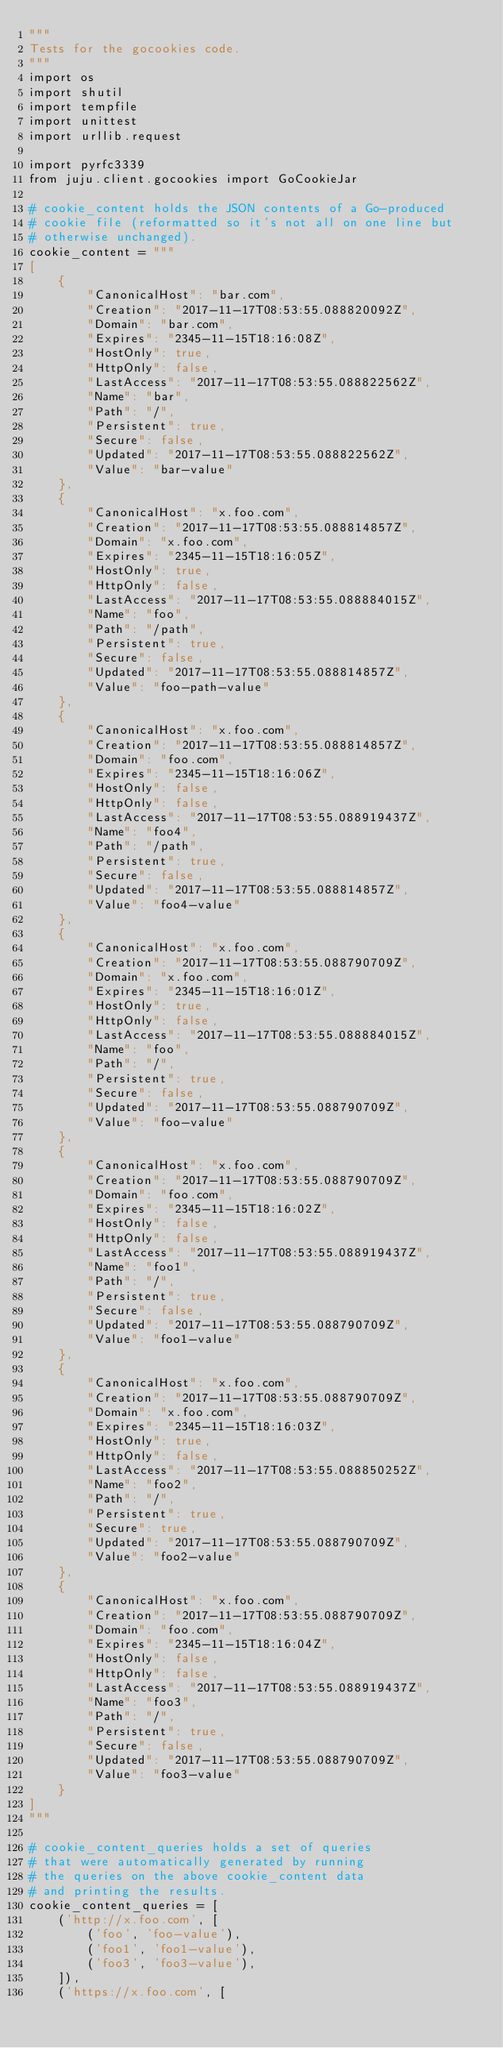<code> <loc_0><loc_0><loc_500><loc_500><_Python_>"""
Tests for the gocookies code.
"""
import os
import shutil
import tempfile
import unittest
import urllib.request

import pyrfc3339
from juju.client.gocookies import GoCookieJar

# cookie_content holds the JSON contents of a Go-produced
# cookie file (reformatted so it's not all on one line but
# otherwise unchanged).
cookie_content = """
[
    {
        "CanonicalHost": "bar.com",
        "Creation": "2017-11-17T08:53:55.088820092Z",
        "Domain": "bar.com",
        "Expires": "2345-11-15T18:16:08Z",
        "HostOnly": true,
        "HttpOnly": false,
        "LastAccess": "2017-11-17T08:53:55.088822562Z",
        "Name": "bar",
        "Path": "/",
        "Persistent": true,
        "Secure": false,
        "Updated": "2017-11-17T08:53:55.088822562Z",
        "Value": "bar-value"
    },
    {
        "CanonicalHost": "x.foo.com",
        "Creation": "2017-11-17T08:53:55.088814857Z",
        "Domain": "x.foo.com",
        "Expires": "2345-11-15T18:16:05Z",
        "HostOnly": true,
        "HttpOnly": false,
        "LastAccess": "2017-11-17T08:53:55.088884015Z",
        "Name": "foo",
        "Path": "/path",
        "Persistent": true,
        "Secure": false,
        "Updated": "2017-11-17T08:53:55.088814857Z",
        "Value": "foo-path-value"
    },
    {
        "CanonicalHost": "x.foo.com",
        "Creation": "2017-11-17T08:53:55.088814857Z",
        "Domain": "foo.com",
        "Expires": "2345-11-15T18:16:06Z",
        "HostOnly": false,
        "HttpOnly": false,
        "LastAccess": "2017-11-17T08:53:55.088919437Z",
        "Name": "foo4",
        "Path": "/path",
        "Persistent": true,
        "Secure": false,
        "Updated": "2017-11-17T08:53:55.088814857Z",
        "Value": "foo4-value"
    },
    {
        "CanonicalHost": "x.foo.com",
        "Creation": "2017-11-17T08:53:55.088790709Z",
        "Domain": "x.foo.com",
        "Expires": "2345-11-15T18:16:01Z",
        "HostOnly": true,
        "HttpOnly": false,
        "LastAccess": "2017-11-17T08:53:55.088884015Z",
        "Name": "foo",
        "Path": "/",
        "Persistent": true,
        "Secure": false,
        "Updated": "2017-11-17T08:53:55.088790709Z",
        "Value": "foo-value"
    },
    {
        "CanonicalHost": "x.foo.com",
        "Creation": "2017-11-17T08:53:55.088790709Z",
        "Domain": "foo.com",
        "Expires": "2345-11-15T18:16:02Z",
        "HostOnly": false,
        "HttpOnly": false,
        "LastAccess": "2017-11-17T08:53:55.088919437Z",
        "Name": "foo1",
        "Path": "/",
        "Persistent": true,
        "Secure": false,
        "Updated": "2017-11-17T08:53:55.088790709Z",
        "Value": "foo1-value"
    },
    {
        "CanonicalHost": "x.foo.com",
        "Creation": "2017-11-17T08:53:55.088790709Z",
        "Domain": "x.foo.com",
        "Expires": "2345-11-15T18:16:03Z",
        "HostOnly": true,
        "HttpOnly": false,
        "LastAccess": "2017-11-17T08:53:55.088850252Z",
        "Name": "foo2",
        "Path": "/",
        "Persistent": true,
        "Secure": true,
        "Updated": "2017-11-17T08:53:55.088790709Z",
        "Value": "foo2-value"
    },
    {
        "CanonicalHost": "x.foo.com",
        "Creation": "2017-11-17T08:53:55.088790709Z",
        "Domain": "foo.com",
        "Expires": "2345-11-15T18:16:04Z",
        "HostOnly": false,
        "HttpOnly": false,
        "LastAccess": "2017-11-17T08:53:55.088919437Z",
        "Name": "foo3",
        "Path": "/",
        "Persistent": true,
        "Secure": false,
        "Updated": "2017-11-17T08:53:55.088790709Z",
        "Value": "foo3-value"
    }
]
"""

# cookie_content_queries holds a set of queries
# that were automatically generated by running
# the queries on the above cookie_content data
# and printing the results.
cookie_content_queries = [
    ('http://x.foo.com', [
        ('foo', 'foo-value'),
        ('foo1', 'foo1-value'),
        ('foo3', 'foo3-value'),
    ]),
    ('https://x.foo.com', [</code> 